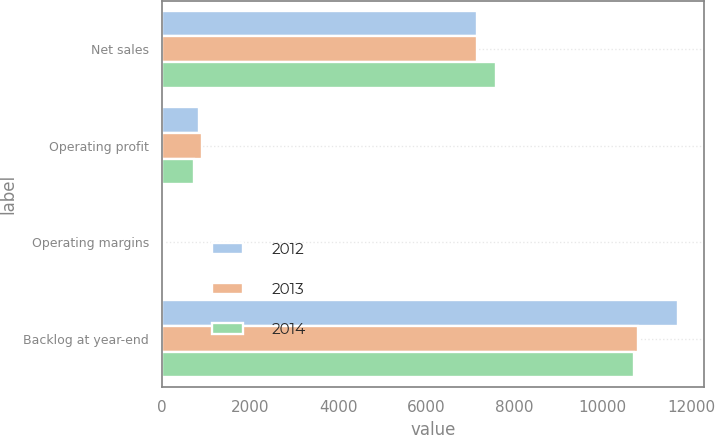Convert chart. <chart><loc_0><loc_0><loc_500><loc_500><stacked_bar_chart><ecel><fcel>Net sales<fcel>Operating profit<fcel>Operating margins<fcel>Backlog at year-end<nl><fcel>2012<fcel>7147<fcel>843<fcel>11.8<fcel>11700<nl><fcel>2013<fcel>7153<fcel>905<fcel>12.7<fcel>10800<nl><fcel>2014<fcel>7579<fcel>737<fcel>9.7<fcel>10700<nl></chart> 